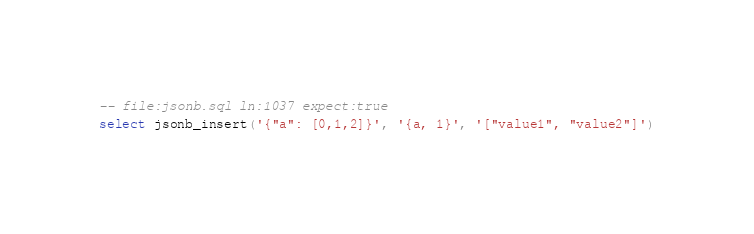Convert code to text. <code><loc_0><loc_0><loc_500><loc_500><_SQL_>-- file:jsonb.sql ln:1037 expect:true
select jsonb_insert('{"a": [0,1,2]}', '{a, 1}', '["value1", "value2"]')
</code> 